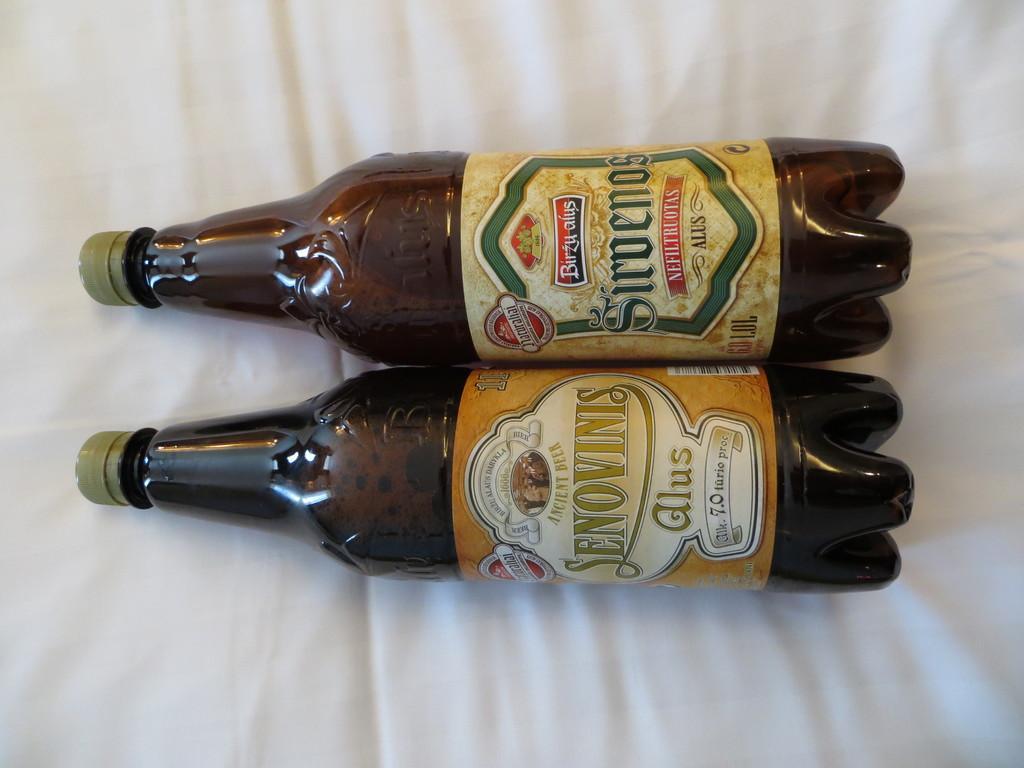How would you summarize this image in a sentence or two? This picture is mainly highlighted with two bottles which are laid on a white cloth. 